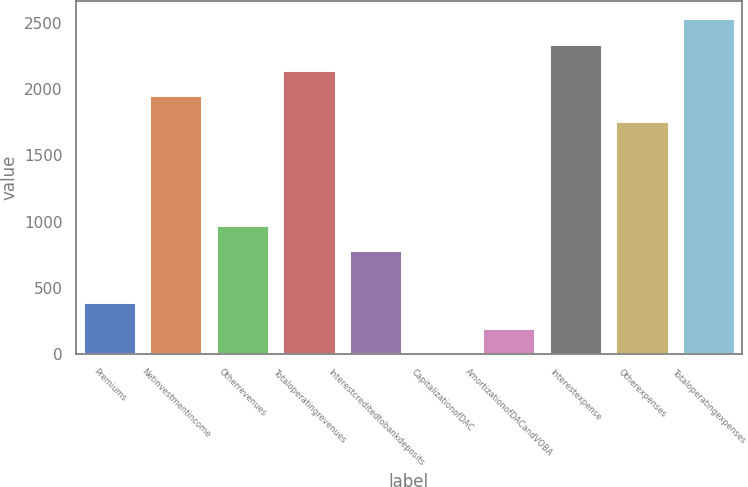Convert chart to OTSL. <chart><loc_0><loc_0><loc_500><loc_500><bar_chart><fcel>Premiums<fcel>Netinvestmentincome<fcel>Otherrevenues<fcel>Totaloperatingrevenues<fcel>Interestcreditedtobankdeposits<fcel>CapitalizationofDAC<fcel>AmortizationofDACandVOBA<fcel>Interestexpense<fcel>Otherexpenses<fcel>Totaloperatingexpenses<nl><fcel>393<fcel>1953<fcel>978<fcel>2148<fcel>783<fcel>3<fcel>198<fcel>2343<fcel>1758<fcel>2538<nl></chart> 